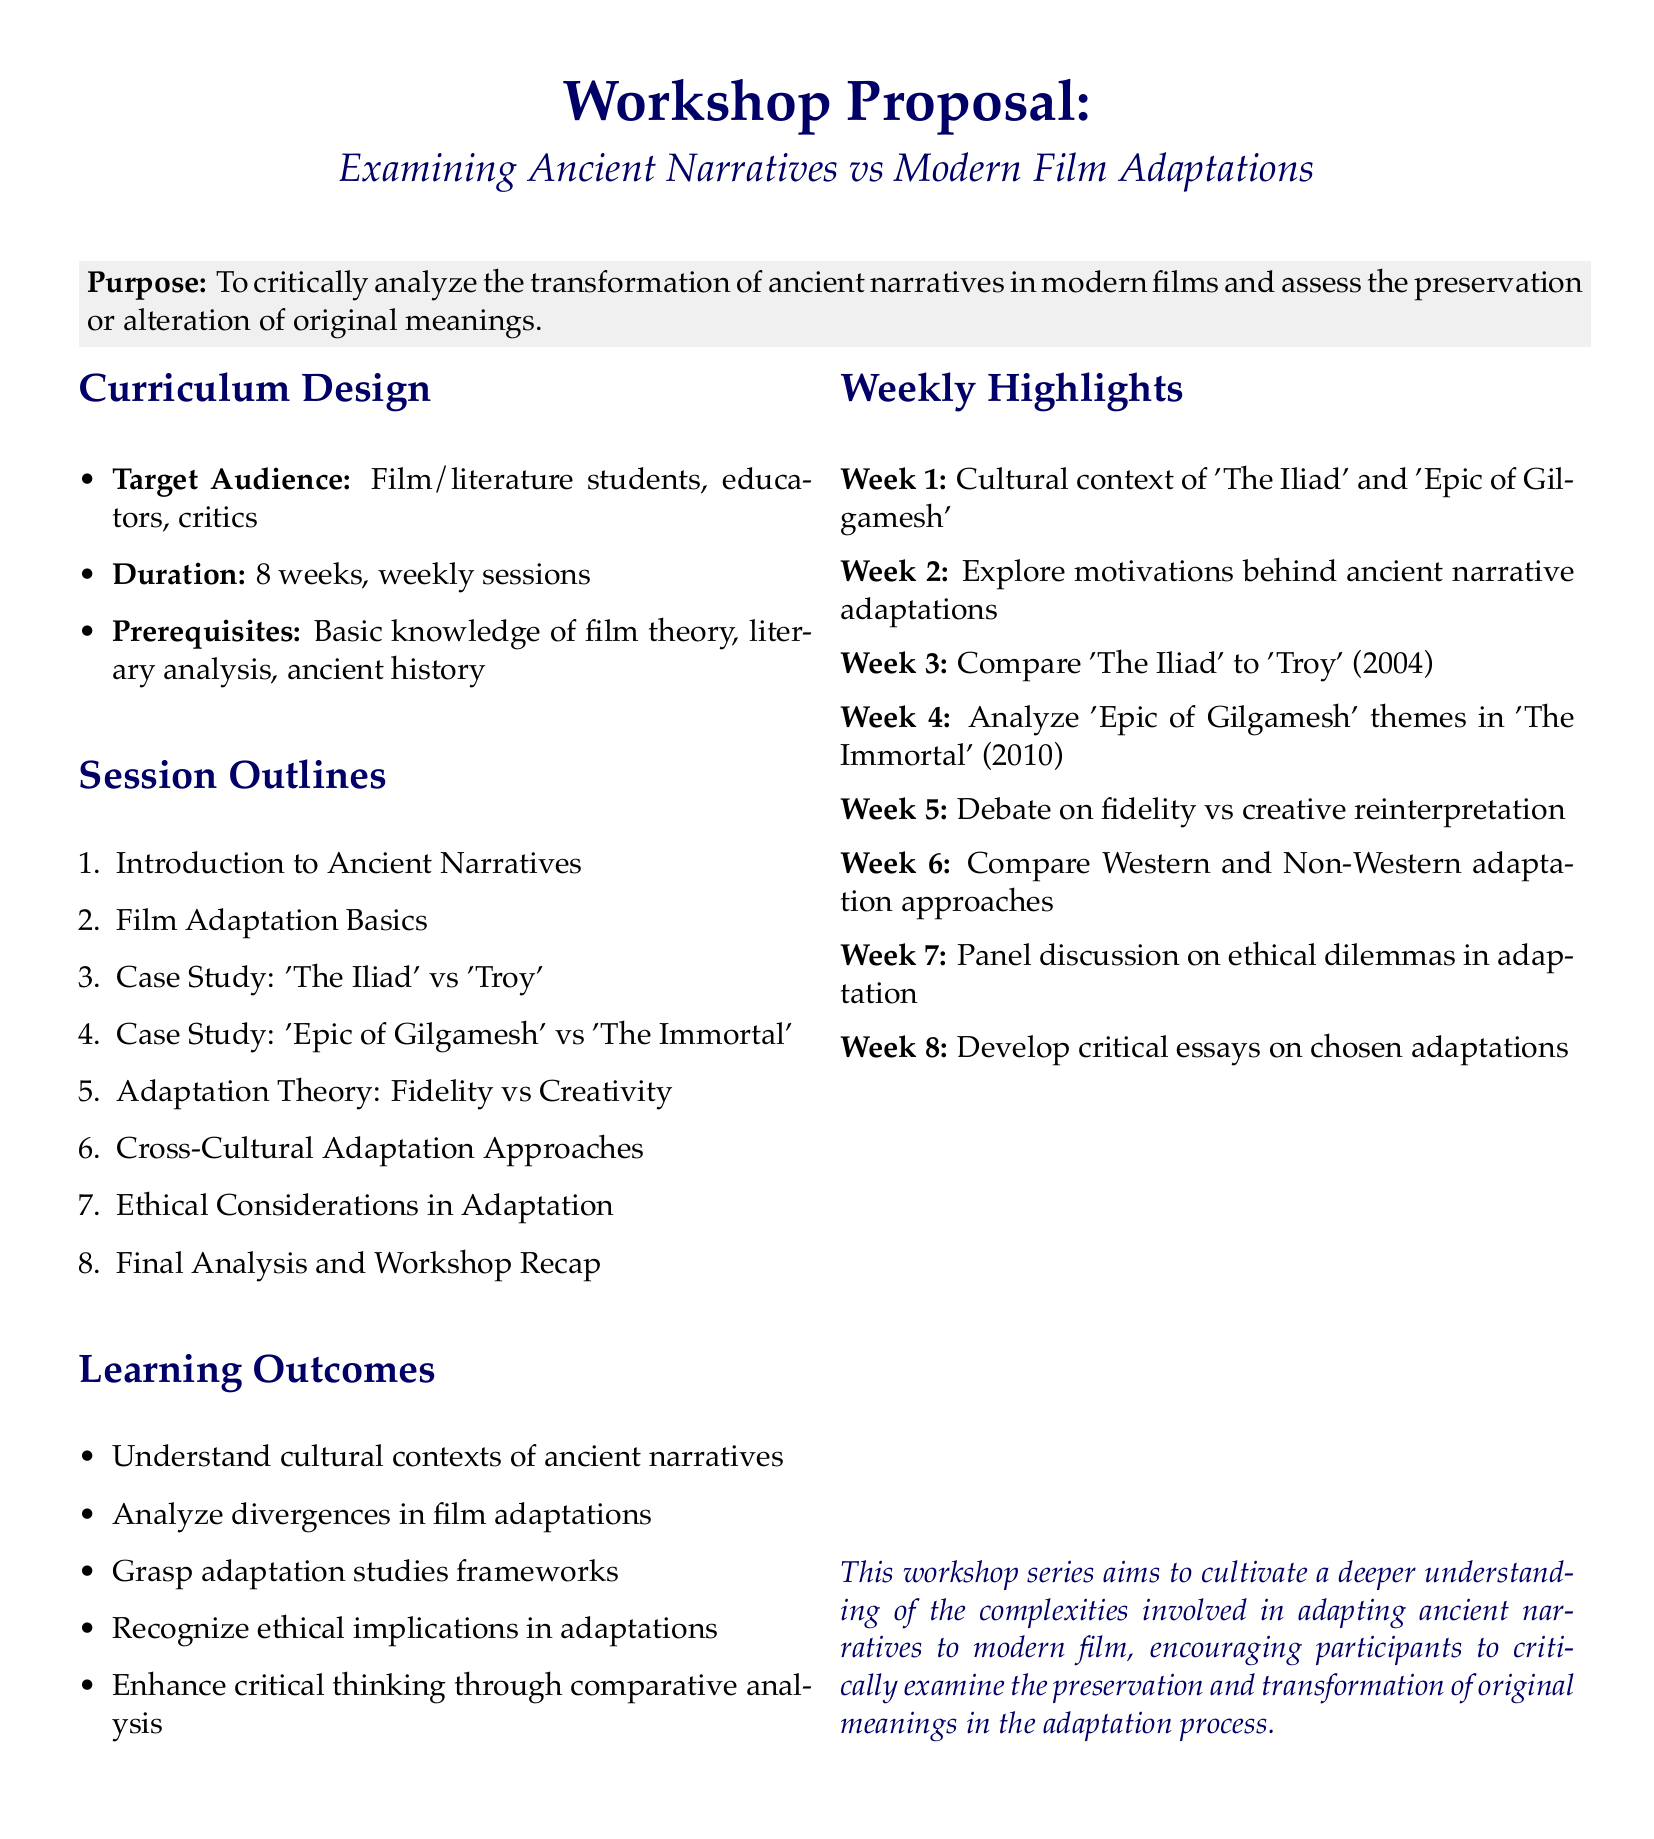What is the target audience for the workshop? The target audience is specified as film/literature students, educators, critics.
Answer: film/literature students, educators, critics How many weeks does the workshop series last? The duration of the workshop series is stated directly in the document.
Answer: 8 weeks What is the first session topic? The first session topic is listed in the session outlines section.
Answer: Introduction to Ancient Narratives What is the focus of the fourth week? The document outlines the focus for each week, indicating specific case studies.
Answer: Analyze 'Epic of Gilgamesh' themes in 'The Immortal' (2010) What ethical considerations are included in the session outlines? Ethical considerations in adaptation is mentioned under session outlines.
Answer: Ethical Considerations in Adaptation What learning outcome involves critical thinking? The document lists specific learning outcomes; one explicitly mentions enhancing critical thinking.
Answer: Enhance critical thinking through comparative analysis What case study is discussed in the third week? The case study for the third week is detailed in the weekly highlights section.
Answer: Compare 'The Iliad' to 'Troy' (2004) What is the final activity in the workshop series? The last session includes a specific activity that encapsulates the workshop series.
Answer: Develop critical essays on chosen adaptations 